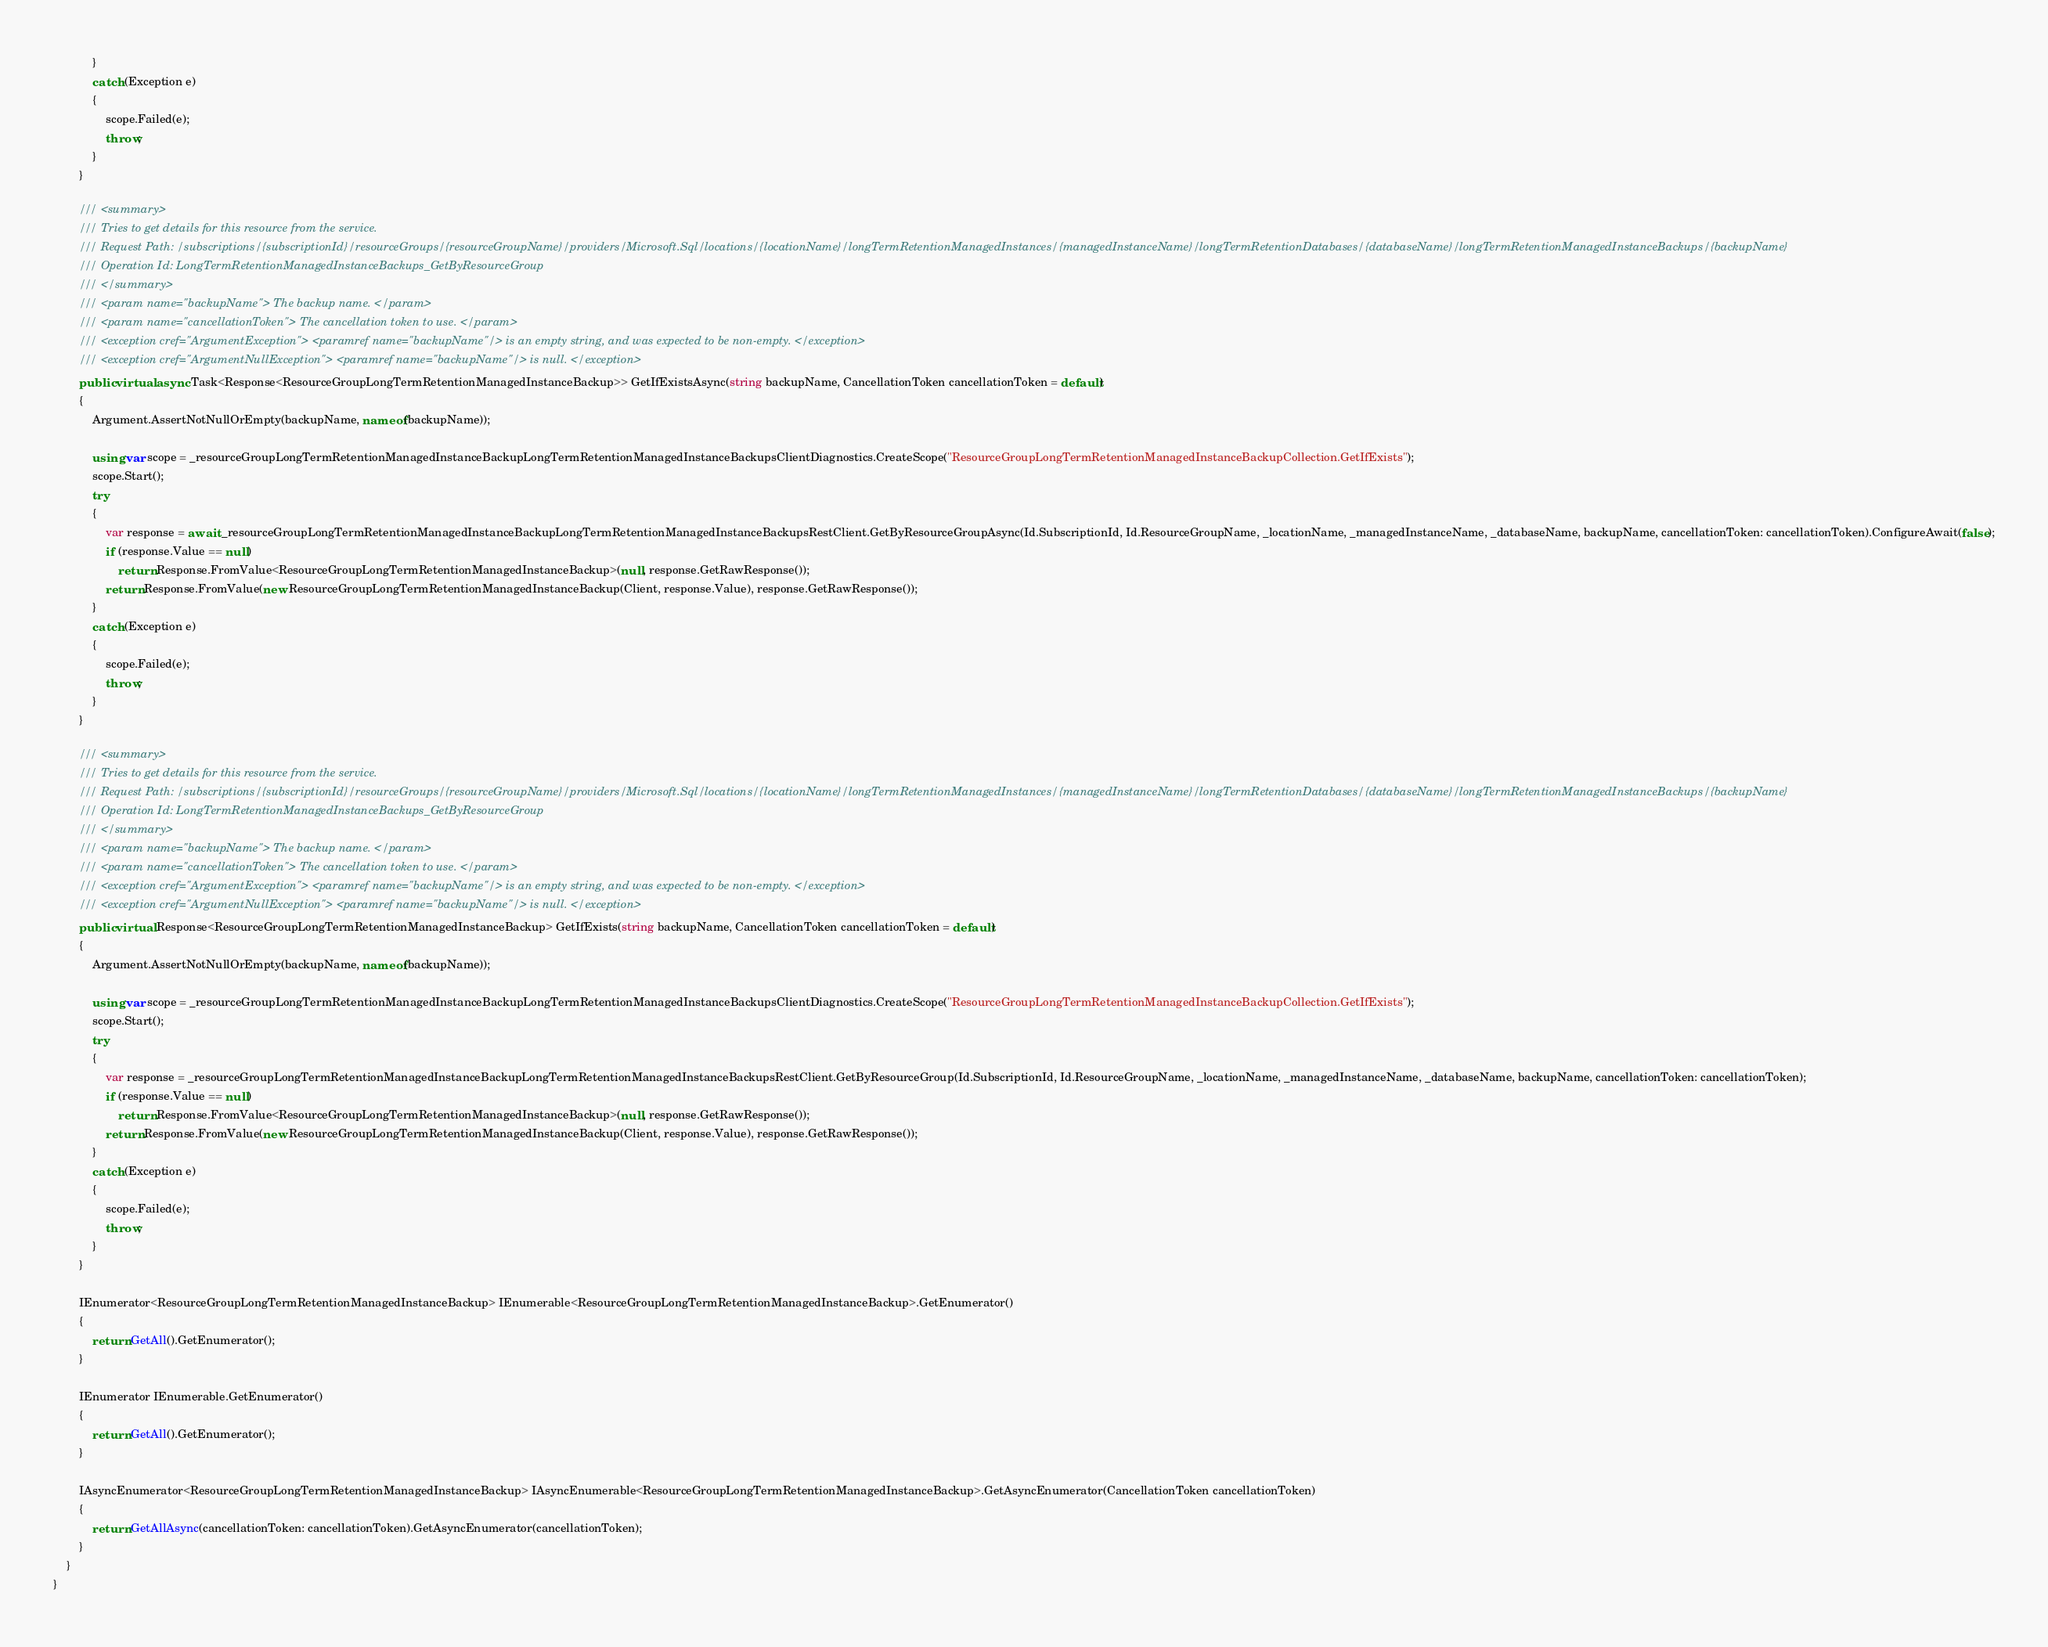<code> <loc_0><loc_0><loc_500><loc_500><_C#_>            }
            catch (Exception e)
            {
                scope.Failed(e);
                throw;
            }
        }

        /// <summary>
        /// Tries to get details for this resource from the service.
        /// Request Path: /subscriptions/{subscriptionId}/resourceGroups/{resourceGroupName}/providers/Microsoft.Sql/locations/{locationName}/longTermRetentionManagedInstances/{managedInstanceName}/longTermRetentionDatabases/{databaseName}/longTermRetentionManagedInstanceBackups/{backupName}
        /// Operation Id: LongTermRetentionManagedInstanceBackups_GetByResourceGroup
        /// </summary>
        /// <param name="backupName"> The backup name. </param>
        /// <param name="cancellationToken"> The cancellation token to use. </param>
        /// <exception cref="ArgumentException"> <paramref name="backupName"/> is an empty string, and was expected to be non-empty. </exception>
        /// <exception cref="ArgumentNullException"> <paramref name="backupName"/> is null. </exception>
        public virtual async Task<Response<ResourceGroupLongTermRetentionManagedInstanceBackup>> GetIfExistsAsync(string backupName, CancellationToken cancellationToken = default)
        {
            Argument.AssertNotNullOrEmpty(backupName, nameof(backupName));

            using var scope = _resourceGroupLongTermRetentionManagedInstanceBackupLongTermRetentionManagedInstanceBackupsClientDiagnostics.CreateScope("ResourceGroupLongTermRetentionManagedInstanceBackupCollection.GetIfExists");
            scope.Start();
            try
            {
                var response = await _resourceGroupLongTermRetentionManagedInstanceBackupLongTermRetentionManagedInstanceBackupsRestClient.GetByResourceGroupAsync(Id.SubscriptionId, Id.ResourceGroupName, _locationName, _managedInstanceName, _databaseName, backupName, cancellationToken: cancellationToken).ConfigureAwait(false);
                if (response.Value == null)
                    return Response.FromValue<ResourceGroupLongTermRetentionManagedInstanceBackup>(null, response.GetRawResponse());
                return Response.FromValue(new ResourceGroupLongTermRetentionManagedInstanceBackup(Client, response.Value), response.GetRawResponse());
            }
            catch (Exception e)
            {
                scope.Failed(e);
                throw;
            }
        }

        /// <summary>
        /// Tries to get details for this resource from the service.
        /// Request Path: /subscriptions/{subscriptionId}/resourceGroups/{resourceGroupName}/providers/Microsoft.Sql/locations/{locationName}/longTermRetentionManagedInstances/{managedInstanceName}/longTermRetentionDatabases/{databaseName}/longTermRetentionManagedInstanceBackups/{backupName}
        /// Operation Id: LongTermRetentionManagedInstanceBackups_GetByResourceGroup
        /// </summary>
        /// <param name="backupName"> The backup name. </param>
        /// <param name="cancellationToken"> The cancellation token to use. </param>
        /// <exception cref="ArgumentException"> <paramref name="backupName"/> is an empty string, and was expected to be non-empty. </exception>
        /// <exception cref="ArgumentNullException"> <paramref name="backupName"/> is null. </exception>
        public virtual Response<ResourceGroupLongTermRetentionManagedInstanceBackup> GetIfExists(string backupName, CancellationToken cancellationToken = default)
        {
            Argument.AssertNotNullOrEmpty(backupName, nameof(backupName));

            using var scope = _resourceGroupLongTermRetentionManagedInstanceBackupLongTermRetentionManagedInstanceBackupsClientDiagnostics.CreateScope("ResourceGroupLongTermRetentionManagedInstanceBackupCollection.GetIfExists");
            scope.Start();
            try
            {
                var response = _resourceGroupLongTermRetentionManagedInstanceBackupLongTermRetentionManagedInstanceBackupsRestClient.GetByResourceGroup(Id.SubscriptionId, Id.ResourceGroupName, _locationName, _managedInstanceName, _databaseName, backupName, cancellationToken: cancellationToken);
                if (response.Value == null)
                    return Response.FromValue<ResourceGroupLongTermRetentionManagedInstanceBackup>(null, response.GetRawResponse());
                return Response.FromValue(new ResourceGroupLongTermRetentionManagedInstanceBackup(Client, response.Value), response.GetRawResponse());
            }
            catch (Exception e)
            {
                scope.Failed(e);
                throw;
            }
        }

        IEnumerator<ResourceGroupLongTermRetentionManagedInstanceBackup> IEnumerable<ResourceGroupLongTermRetentionManagedInstanceBackup>.GetEnumerator()
        {
            return GetAll().GetEnumerator();
        }

        IEnumerator IEnumerable.GetEnumerator()
        {
            return GetAll().GetEnumerator();
        }

        IAsyncEnumerator<ResourceGroupLongTermRetentionManagedInstanceBackup> IAsyncEnumerable<ResourceGroupLongTermRetentionManagedInstanceBackup>.GetAsyncEnumerator(CancellationToken cancellationToken)
        {
            return GetAllAsync(cancellationToken: cancellationToken).GetAsyncEnumerator(cancellationToken);
        }
    }
}
</code> 